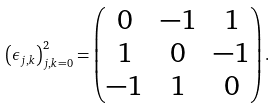<formula> <loc_0><loc_0><loc_500><loc_500>\left ( \epsilon _ { j , k } \right ) _ { j , k = 0 } ^ { 2 } = \begin{pmatrix} 0 & - 1 & 1 \\ 1 & 0 & - 1 \\ - 1 & 1 & 0 \end{pmatrix} .</formula> 